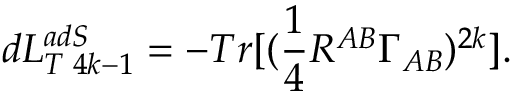<formula> <loc_0><loc_0><loc_500><loc_500>d L _ { T \, 4 k - 1 } ^ { a d S } = - T r [ ( \frac { 1 } { 4 } R ^ { A B } \Gamma _ { A B } ) ^ { 2 k } ] .</formula> 